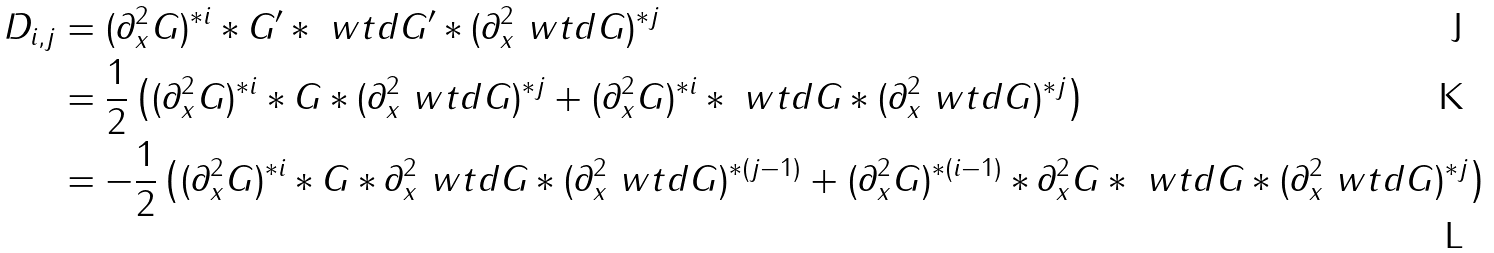<formula> <loc_0><loc_0><loc_500><loc_500>D _ { i , j } & = ( \partial _ { x } ^ { 2 } G ) ^ { * i } * G ^ { \prime } * \ w t d { G ^ { \prime } } * ( \partial _ { x } ^ { 2 } \ w t d G ) ^ { * j } \\ & = \frac { 1 } { 2 } \left ( ( \partial _ { x } ^ { 2 } G ) ^ { * i } * G * ( \partial _ { x } ^ { 2 } \ w t d G ) ^ { * j } + ( \partial _ { x } ^ { 2 } G ) ^ { * i } * \ w t d G * ( \partial _ { x } ^ { 2 } \ w t d G ) ^ { * j } \right ) \\ & = - \frac { 1 } { 2 } \left ( ( \partial _ { x } ^ { 2 } G ) ^ { * i } * G * \partial _ { x } ^ { 2 } \ w t d G * ( \partial _ { x } ^ { 2 } \ w t d G ) ^ { * ( j - 1 ) } + ( \partial _ { x } ^ { 2 } G ) ^ { * ( i - 1 ) } * \partial _ { x } ^ { 2 } G * \ w t d G * ( \partial _ { x } ^ { 2 } \ w t d G ) ^ { * j } \right )</formula> 